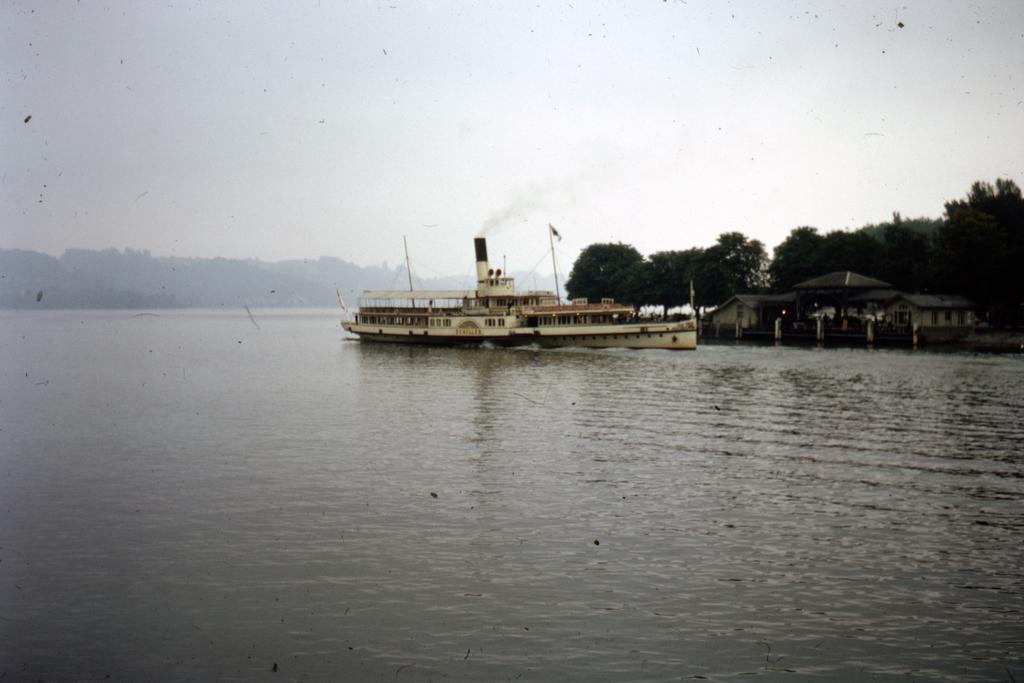Can you describe this image briefly? In the picture I can see a boat on the water. In the background I can see trees, the sky, houses, smoke and some other objects. 